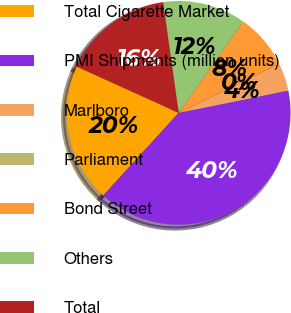Convert chart to OTSL. <chart><loc_0><loc_0><loc_500><loc_500><pie_chart><fcel>Total Cigarette Market<fcel>PMI Shipments (million units)<fcel>Marlboro<fcel>Parliament<fcel>Bond Street<fcel>Others<fcel>Total<nl><fcel>20.0%<fcel>39.99%<fcel>4.0%<fcel>0.01%<fcel>8.0%<fcel>12.0%<fcel>16.0%<nl></chart> 